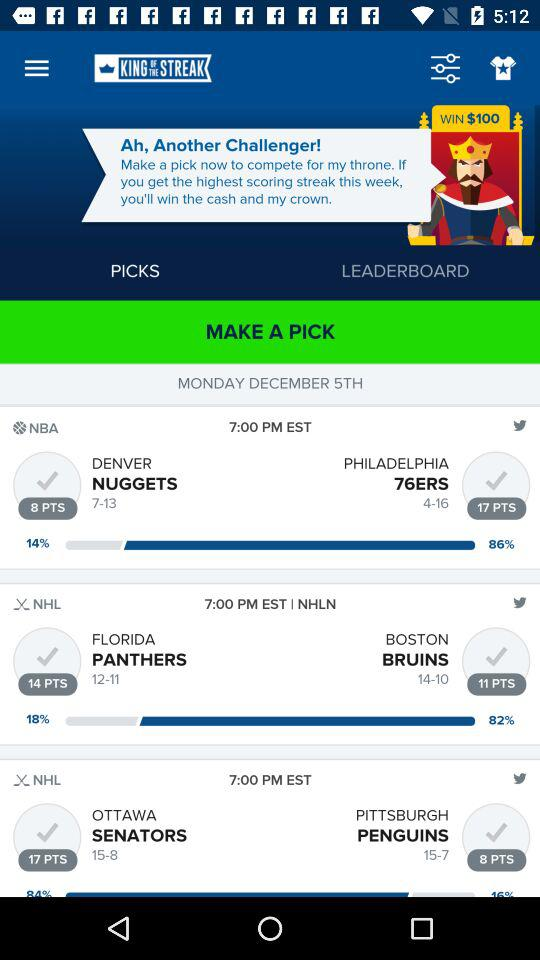What is the timing of the match between the Denver Nuggets and Philadelphia 76ERS? The time of the match is 7:00 PM EST. 